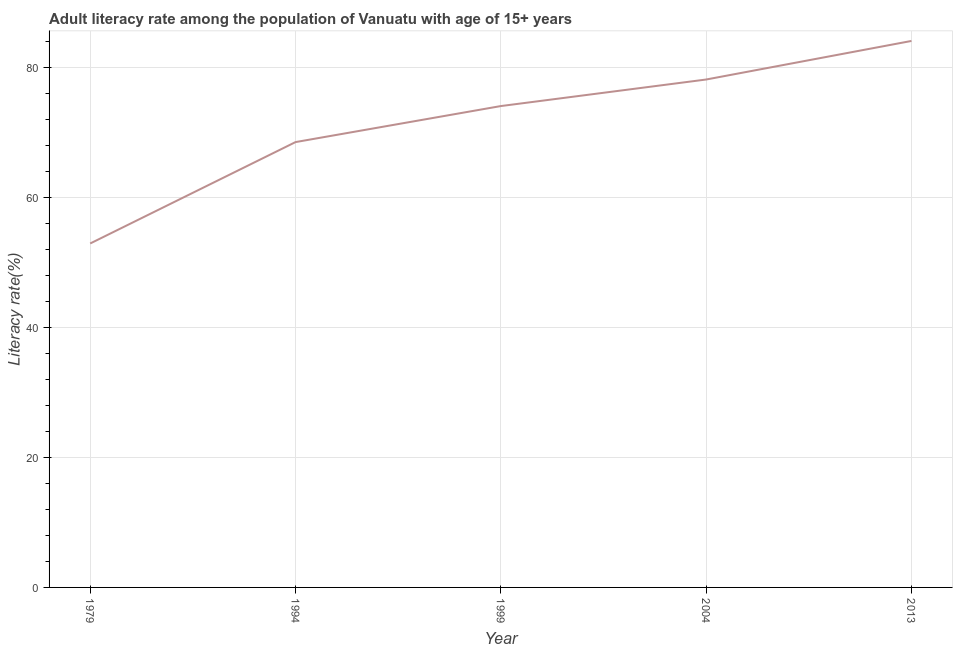What is the adult literacy rate in 1979?
Make the answer very short. 52.87. Across all years, what is the maximum adult literacy rate?
Keep it short and to the point. 84.01. Across all years, what is the minimum adult literacy rate?
Ensure brevity in your answer.  52.87. In which year was the adult literacy rate maximum?
Offer a terse response. 2013. In which year was the adult literacy rate minimum?
Ensure brevity in your answer.  1979. What is the sum of the adult literacy rate?
Your answer should be very brief. 357.42. What is the difference between the adult literacy rate in 1979 and 2013?
Your response must be concise. -31.14. What is the average adult literacy rate per year?
Provide a short and direct response. 71.48. What is the median adult literacy rate?
Your response must be concise. 74. In how many years, is the adult literacy rate greater than 52 %?
Provide a succinct answer. 5. Do a majority of the years between 2013 and 1994 (inclusive) have adult literacy rate greater than 64 %?
Provide a succinct answer. Yes. What is the ratio of the adult literacy rate in 1979 to that in 1999?
Make the answer very short. 0.71. What is the difference between the highest and the second highest adult literacy rate?
Ensure brevity in your answer.  5.93. What is the difference between the highest and the lowest adult literacy rate?
Offer a terse response. 31.14. In how many years, is the adult literacy rate greater than the average adult literacy rate taken over all years?
Offer a terse response. 3. How many lines are there?
Offer a terse response. 1. What is the difference between two consecutive major ticks on the Y-axis?
Your answer should be very brief. 20. Does the graph contain any zero values?
Your answer should be very brief. No. Does the graph contain grids?
Provide a short and direct response. Yes. What is the title of the graph?
Provide a short and direct response. Adult literacy rate among the population of Vanuatu with age of 15+ years. What is the label or title of the Y-axis?
Give a very brief answer. Literacy rate(%). What is the Literacy rate(%) of 1979?
Keep it short and to the point. 52.87. What is the Literacy rate(%) in 1994?
Your answer should be very brief. 68.46. What is the Literacy rate(%) of 1999?
Your answer should be very brief. 74. What is the Literacy rate(%) in 2004?
Give a very brief answer. 78.08. What is the Literacy rate(%) of 2013?
Your response must be concise. 84.01. What is the difference between the Literacy rate(%) in 1979 and 1994?
Your answer should be very brief. -15.59. What is the difference between the Literacy rate(%) in 1979 and 1999?
Offer a terse response. -21.13. What is the difference between the Literacy rate(%) in 1979 and 2004?
Ensure brevity in your answer.  -25.21. What is the difference between the Literacy rate(%) in 1979 and 2013?
Your response must be concise. -31.14. What is the difference between the Literacy rate(%) in 1994 and 1999?
Your answer should be very brief. -5.54. What is the difference between the Literacy rate(%) in 1994 and 2004?
Ensure brevity in your answer.  -9.62. What is the difference between the Literacy rate(%) in 1994 and 2013?
Provide a short and direct response. -15.55. What is the difference between the Literacy rate(%) in 1999 and 2004?
Keep it short and to the point. -4.08. What is the difference between the Literacy rate(%) in 1999 and 2013?
Your answer should be compact. -10.01. What is the difference between the Literacy rate(%) in 2004 and 2013?
Your response must be concise. -5.93. What is the ratio of the Literacy rate(%) in 1979 to that in 1994?
Keep it short and to the point. 0.77. What is the ratio of the Literacy rate(%) in 1979 to that in 1999?
Provide a succinct answer. 0.71. What is the ratio of the Literacy rate(%) in 1979 to that in 2004?
Your answer should be compact. 0.68. What is the ratio of the Literacy rate(%) in 1979 to that in 2013?
Provide a succinct answer. 0.63. What is the ratio of the Literacy rate(%) in 1994 to that in 1999?
Give a very brief answer. 0.93. What is the ratio of the Literacy rate(%) in 1994 to that in 2004?
Make the answer very short. 0.88. What is the ratio of the Literacy rate(%) in 1994 to that in 2013?
Offer a terse response. 0.81. What is the ratio of the Literacy rate(%) in 1999 to that in 2004?
Keep it short and to the point. 0.95. What is the ratio of the Literacy rate(%) in 1999 to that in 2013?
Make the answer very short. 0.88. What is the ratio of the Literacy rate(%) in 2004 to that in 2013?
Offer a terse response. 0.93. 